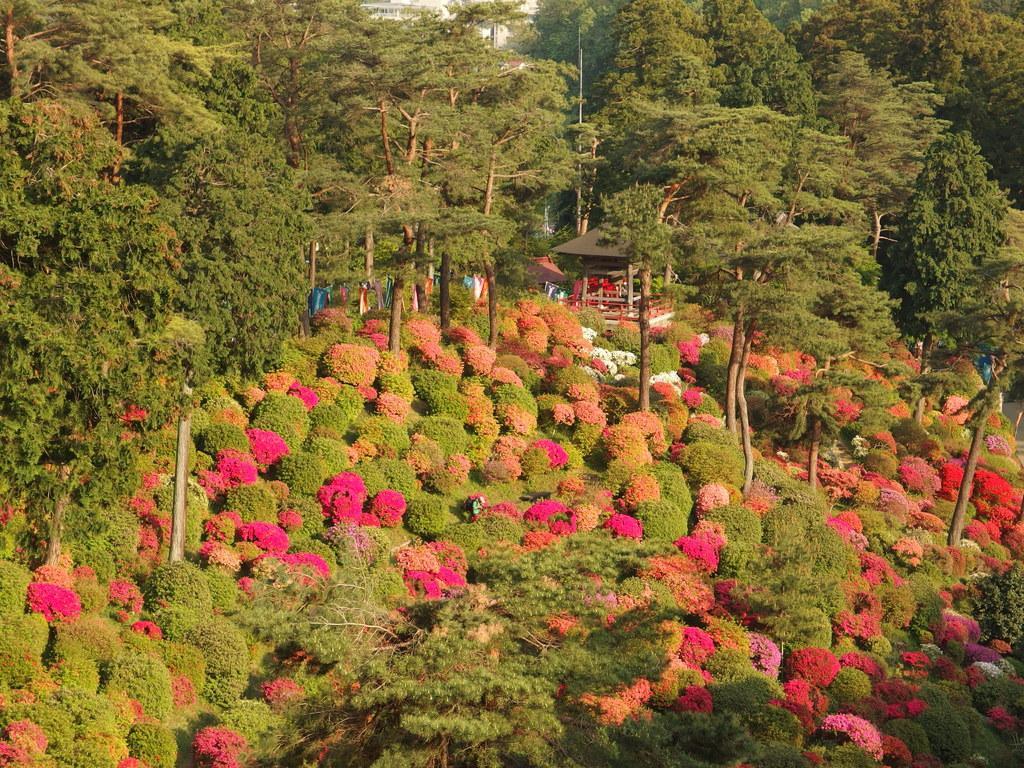Can you describe this image briefly? This place is looking like a garden. At the bottom, I can see many flower plants. In the background there are many trees and also there is shed and few people. 